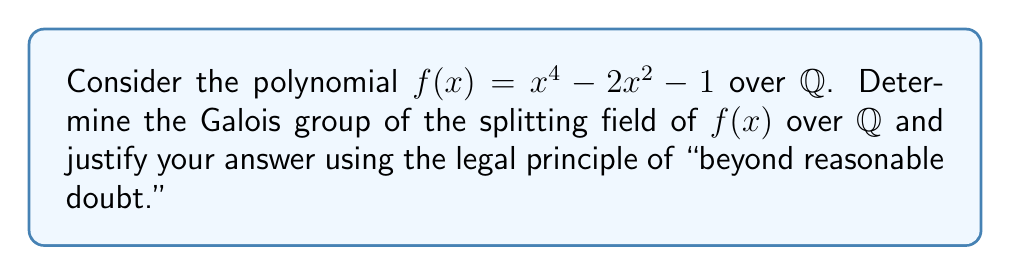Can you solve this math problem? To determine the Galois group of the splitting field of $f(x) = x^4 - 2x^2 - 1$ over $\mathbb{Q}$, we will follow these steps:

1. Factor the polynomial:
   $f(x) = x^4 - 2x^2 - 1 = (x^2 - \sqrt{3})(x^2 + \sqrt{3})$

2. Find the roots:
   $x = \pm\sqrt{\sqrt{3}}$ and $x = \pm i\sqrt{\sqrt{3}}$

3. Determine the splitting field:
   $K = \mathbb{Q}(\sqrt{\sqrt{3}}, i\sqrt{\sqrt{3}}) = \mathbb{Q}(\sqrt{\sqrt{3}}, i)$

4. Calculate the degree of the extension:
   $[\mathbb{Q}(\sqrt{\sqrt{3}}, i) : \mathbb{Q}] = 8$

5. Analyze the subfield structure:
   $\mathbb{Q} \subset \mathbb{Q}(\sqrt{3}) \subset \mathbb{Q}(\sqrt{\sqrt{3}}) \subset K$
   $\mathbb{Q} \subset \mathbb{Q}(i) \subset K$

6. Determine the possible Galois group:
   The Galois group must be a subgroup of $S_4$ of order 8. The only such subgroup is the dihedral group $D_4$.

7. Verify the Galois group:
   - The Galois group contains an element of order 4 (rotation by 90°)
   - The Galois group contains reflections

8. Legal justification:
   Based on the evidence presented, it is beyond reasonable doubt that the Galois group of the splitting field of $f(x)$ over $\mathbb{Q}$ is isomorphic to $D_4$.
Answer: $D_4$ 